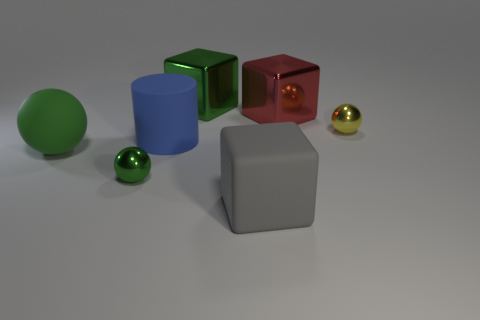Subtract all blue cubes. Subtract all gray cylinders. How many cubes are left? 3 Add 1 yellow metal objects. How many objects exist? 8 Subtract all blocks. How many objects are left? 4 Add 4 tiny green metallic balls. How many tiny green metallic balls exist? 5 Subtract 0 purple cylinders. How many objects are left? 7 Subtract all matte cylinders. Subtract all large spheres. How many objects are left? 5 Add 4 red metal cubes. How many red metal cubes are left? 5 